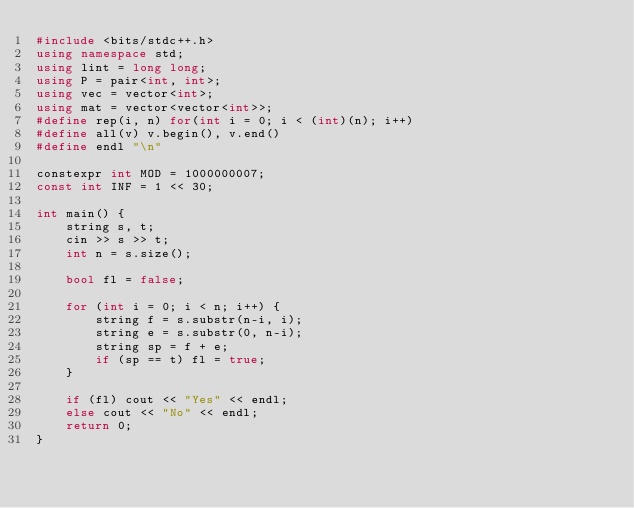Convert code to text. <code><loc_0><loc_0><loc_500><loc_500><_C++_>#include <bits/stdc++.h>
using namespace std;
using lint = long long;
using P = pair<int, int>;
using vec = vector<int>;
using mat = vector<vector<int>>;
#define rep(i, n) for(int i = 0; i < (int)(n); i++)
#define all(v) v.begin(), v.end()
#define endl "\n"

constexpr int MOD = 1000000007;
const int INF = 1 << 30;

int main() {
    string s, t;
    cin >> s >> t;
    int n = s.size();

    bool fl = false;

    for (int i = 0; i < n; i++) {
        string f = s.substr(n-i, i);
        string e = s.substr(0, n-i);
        string sp = f + e;
        if (sp == t) fl = true;
    }

    if (fl) cout << "Yes" << endl;
    else cout << "No" << endl;
    return 0;
}</code> 